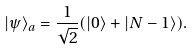Convert formula to latex. <formula><loc_0><loc_0><loc_500><loc_500>| \psi \rangle _ { a } = \frac { 1 } { \sqrt { 2 } } ( | 0 \rangle + | { N - 1 } \rangle ) .</formula> 